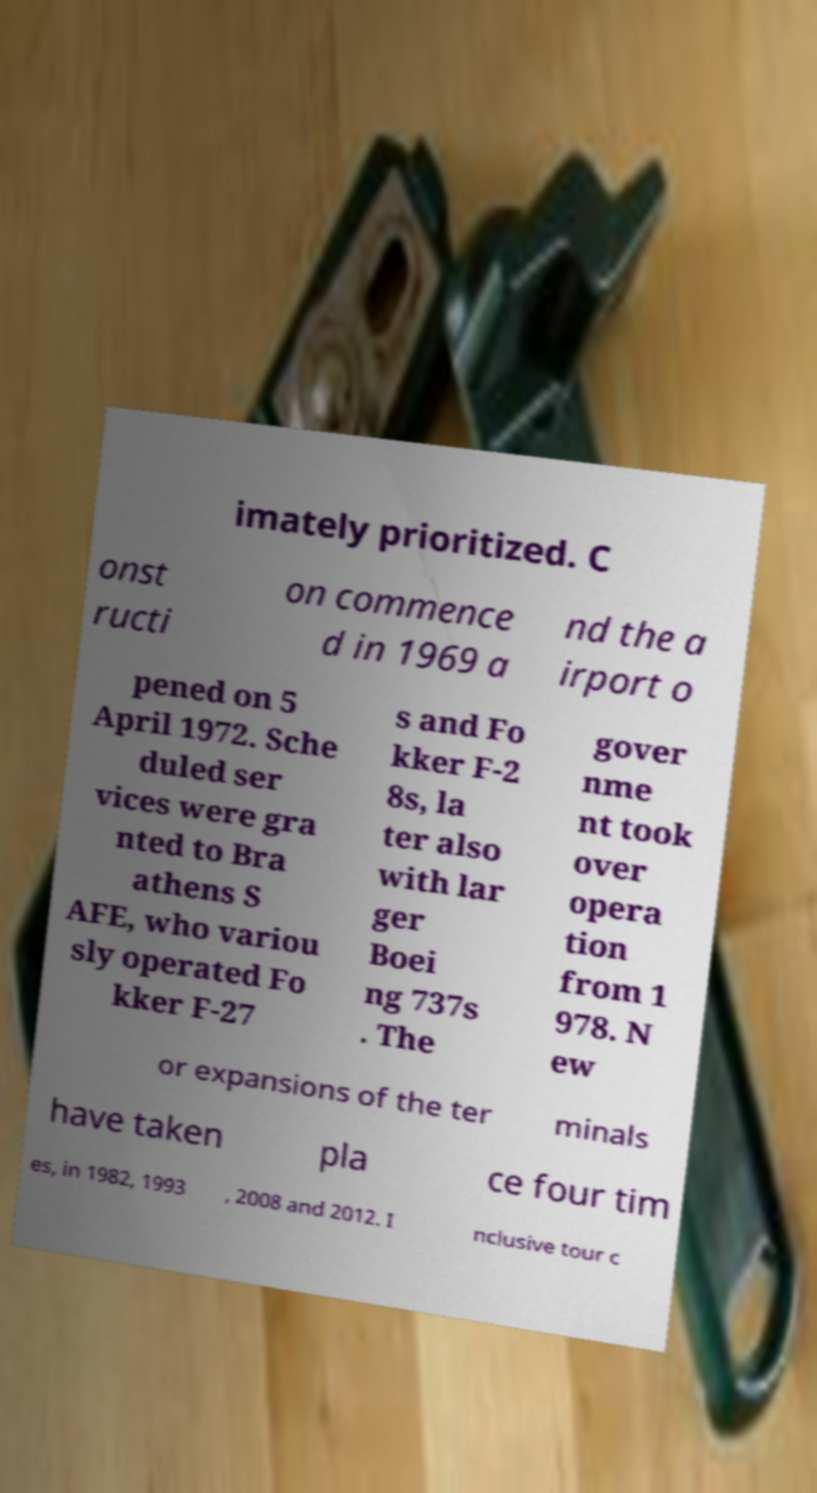Please identify and transcribe the text found in this image. imately prioritized. C onst ructi on commence d in 1969 a nd the a irport o pened on 5 April 1972. Sche duled ser vices were gra nted to Bra athens S AFE, who variou sly operated Fo kker F-27 s and Fo kker F-2 8s, la ter also with lar ger Boei ng 737s . The gover nme nt took over opera tion from 1 978. N ew or expansions of the ter minals have taken pla ce four tim es, in 1982, 1993 , 2008 and 2012. I nclusive tour c 